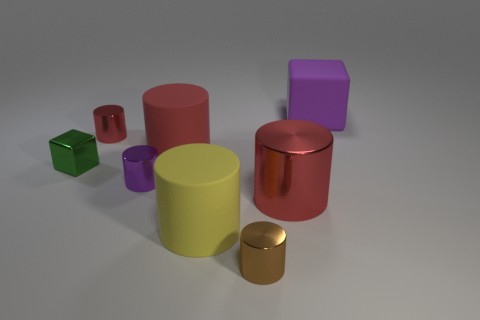Is there a tiny metallic thing that has the same shape as the yellow rubber object? yes 